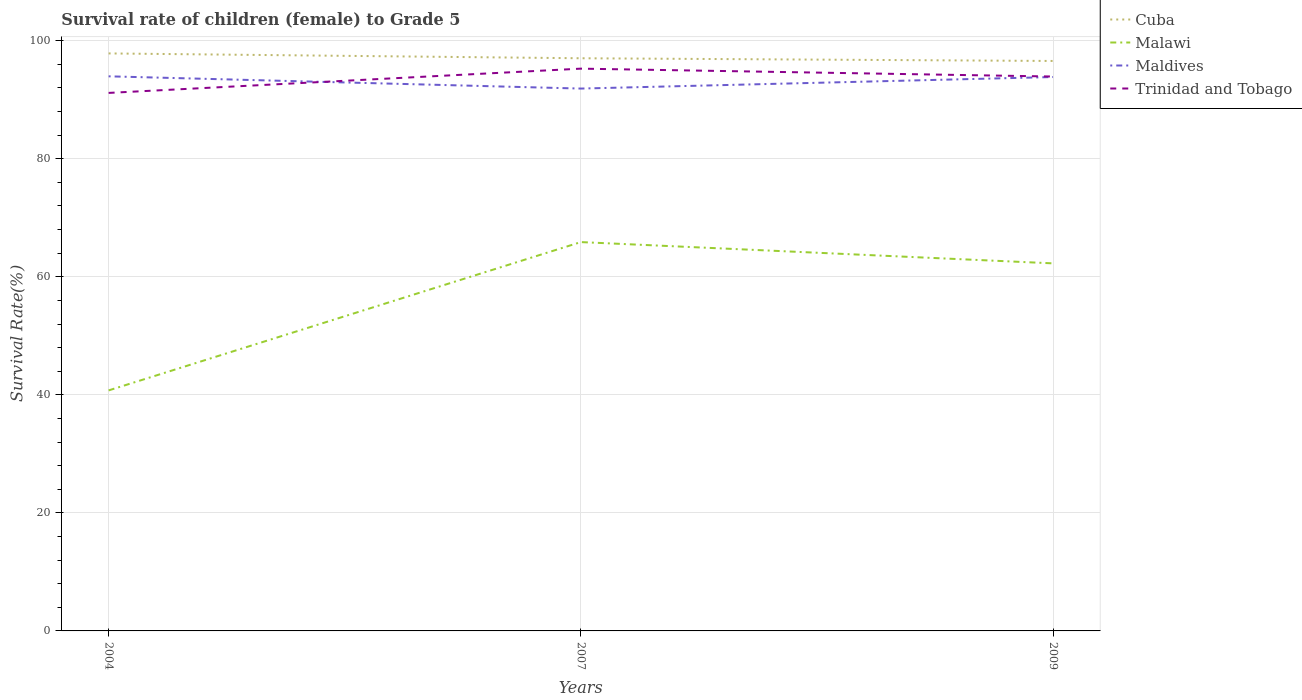How many different coloured lines are there?
Provide a short and direct response. 4. Does the line corresponding to Cuba intersect with the line corresponding to Malawi?
Keep it short and to the point. No. Across all years, what is the maximum survival rate of female children to grade 5 in Cuba?
Offer a very short reply. 96.57. What is the total survival rate of female children to grade 5 in Cuba in the graph?
Your response must be concise. 0.46. What is the difference between the highest and the second highest survival rate of female children to grade 5 in Maldives?
Make the answer very short. 2.07. What is the difference between the highest and the lowest survival rate of female children to grade 5 in Cuba?
Offer a very short reply. 1. Is the survival rate of female children to grade 5 in Cuba strictly greater than the survival rate of female children to grade 5 in Maldives over the years?
Your answer should be very brief. No. Does the graph contain grids?
Provide a short and direct response. Yes. How are the legend labels stacked?
Ensure brevity in your answer.  Vertical. What is the title of the graph?
Make the answer very short. Survival rate of children (female) to Grade 5. Does "Chad" appear as one of the legend labels in the graph?
Make the answer very short. No. What is the label or title of the Y-axis?
Make the answer very short. Survival Rate(%). What is the Survival Rate(%) of Cuba in 2004?
Give a very brief answer. 97.84. What is the Survival Rate(%) of Malawi in 2004?
Your response must be concise. 40.75. What is the Survival Rate(%) in Maldives in 2004?
Offer a terse response. 93.96. What is the Survival Rate(%) in Trinidad and Tobago in 2004?
Keep it short and to the point. 91.15. What is the Survival Rate(%) in Cuba in 2007?
Your answer should be very brief. 97.03. What is the Survival Rate(%) in Malawi in 2007?
Provide a succinct answer. 65.88. What is the Survival Rate(%) in Maldives in 2007?
Offer a very short reply. 91.89. What is the Survival Rate(%) in Trinidad and Tobago in 2007?
Provide a succinct answer. 95.27. What is the Survival Rate(%) of Cuba in 2009?
Give a very brief answer. 96.57. What is the Survival Rate(%) in Malawi in 2009?
Your answer should be very brief. 62.27. What is the Survival Rate(%) of Maldives in 2009?
Give a very brief answer. 93.84. What is the Survival Rate(%) in Trinidad and Tobago in 2009?
Offer a terse response. 93.93. Across all years, what is the maximum Survival Rate(%) of Cuba?
Make the answer very short. 97.84. Across all years, what is the maximum Survival Rate(%) in Malawi?
Give a very brief answer. 65.88. Across all years, what is the maximum Survival Rate(%) in Maldives?
Your answer should be very brief. 93.96. Across all years, what is the maximum Survival Rate(%) of Trinidad and Tobago?
Your answer should be very brief. 95.27. Across all years, what is the minimum Survival Rate(%) of Cuba?
Keep it short and to the point. 96.57. Across all years, what is the minimum Survival Rate(%) of Malawi?
Ensure brevity in your answer.  40.75. Across all years, what is the minimum Survival Rate(%) of Maldives?
Offer a very short reply. 91.89. Across all years, what is the minimum Survival Rate(%) of Trinidad and Tobago?
Keep it short and to the point. 91.15. What is the total Survival Rate(%) of Cuba in the graph?
Offer a very short reply. 291.44. What is the total Survival Rate(%) of Malawi in the graph?
Ensure brevity in your answer.  168.9. What is the total Survival Rate(%) of Maldives in the graph?
Keep it short and to the point. 279.7. What is the total Survival Rate(%) in Trinidad and Tobago in the graph?
Your response must be concise. 280.35. What is the difference between the Survival Rate(%) in Cuba in 2004 and that in 2007?
Your answer should be compact. 0.82. What is the difference between the Survival Rate(%) of Malawi in 2004 and that in 2007?
Make the answer very short. -25.13. What is the difference between the Survival Rate(%) of Maldives in 2004 and that in 2007?
Your answer should be very brief. 2.07. What is the difference between the Survival Rate(%) of Trinidad and Tobago in 2004 and that in 2007?
Ensure brevity in your answer.  -4.11. What is the difference between the Survival Rate(%) of Cuba in 2004 and that in 2009?
Give a very brief answer. 1.28. What is the difference between the Survival Rate(%) of Malawi in 2004 and that in 2009?
Provide a short and direct response. -21.53. What is the difference between the Survival Rate(%) in Maldives in 2004 and that in 2009?
Make the answer very short. 0.12. What is the difference between the Survival Rate(%) of Trinidad and Tobago in 2004 and that in 2009?
Your answer should be very brief. -2.78. What is the difference between the Survival Rate(%) in Cuba in 2007 and that in 2009?
Offer a very short reply. 0.46. What is the difference between the Survival Rate(%) in Malawi in 2007 and that in 2009?
Keep it short and to the point. 3.6. What is the difference between the Survival Rate(%) in Maldives in 2007 and that in 2009?
Keep it short and to the point. -1.95. What is the difference between the Survival Rate(%) in Trinidad and Tobago in 2007 and that in 2009?
Your answer should be very brief. 1.34. What is the difference between the Survival Rate(%) in Cuba in 2004 and the Survival Rate(%) in Malawi in 2007?
Your answer should be compact. 31.97. What is the difference between the Survival Rate(%) of Cuba in 2004 and the Survival Rate(%) of Maldives in 2007?
Your answer should be very brief. 5.95. What is the difference between the Survival Rate(%) in Cuba in 2004 and the Survival Rate(%) in Trinidad and Tobago in 2007?
Keep it short and to the point. 2.58. What is the difference between the Survival Rate(%) in Malawi in 2004 and the Survival Rate(%) in Maldives in 2007?
Provide a short and direct response. -51.14. What is the difference between the Survival Rate(%) of Malawi in 2004 and the Survival Rate(%) of Trinidad and Tobago in 2007?
Your response must be concise. -54.52. What is the difference between the Survival Rate(%) of Maldives in 2004 and the Survival Rate(%) of Trinidad and Tobago in 2007?
Provide a short and direct response. -1.3. What is the difference between the Survival Rate(%) in Cuba in 2004 and the Survival Rate(%) in Malawi in 2009?
Provide a short and direct response. 35.57. What is the difference between the Survival Rate(%) of Cuba in 2004 and the Survival Rate(%) of Maldives in 2009?
Offer a terse response. 4. What is the difference between the Survival Rate(%) in Cuba in 2004 and the Survival Rate(%) in Trinidad and Tobago in 2009?
Provide a short and direct response. 3.91. What is the difference between the Survival Rate(%) of Malawi in 2004 and the Survival Rate(%) of Maldives in 2009?
Your answer should be very brief. -53.1. What is the difference between the Survival Rate(%) in Malawi in 2004 and the Survival Rate(%) in Trinidad and Tobago in 2009?
Provide a short and direct response. -53.18. What is the difference between the Survival Rate(%) of Maldives in 2004 and the Survival Rate(%) of Trinidad and Tobago in 2009?
Provide a succinct answer. 0.04. What is the difference between the Survival Rate(%) of Cuba in 2007 and the Survival Rate(%) of Malawi in 2009?
Offer a very short reply. 34.75. What is the difference between the Survival Rate(%) in Cuba in 2007 and the Survival Rate(%) in Maldives in 2009?
Your response must be concise. 3.18. What is the difference between the Survival Rate(%) of Cuba in 2007 and the Survival Rate(%) of Trinidad and Tobago in 2009?
Make the answer very short. 3.1. What is the difference between the Survival Rate(%) of Malawi in 2007 and the Survival Rate(%) of Maldives in 2009?
Provide a succinct answer. -27.97. What is the difference between the Survival Rate(%) in Malawi in 2007 and the Survival Rate(%) in Trinidad and Tobago in 2009?
Provide a short and direct response. -28.05. What is the difference between the Survival Rate(%) of Maldives in 2007 and the Survival Rate(%) of Trinidad and Tobago in 2009?
Offer a terse response. -2.04. What is the average Survival Rate(%) in Cuba per year?
Provide a short and direct response. 97.15. What is the average Survival Rate(%) in Malawi per year?
Give a very brief answer. 56.3. What is the average Survival Rate(%) of Maldives per year?
Offer a very short reply. 93.23. What is the average Survival Rate(%) of Trinidad and Tobago per year?
Offer a terse response. 93.45. In the year 2004, what is the difference between the Survival Rate(%) of Cuba and Survival Rate(%) of Malawi?
Keep it short and to the point. 57.1. In the year 2004, what is the difference between the Survival Rate(%) of Cuba and Survival Rate(%) of Maldives?
Provide a short and direct response. 3.88. In the year 2004, what is the difference between the Survival Rate(%) of Cuba and Survival Rate(%) of Trinidad and Tobago?
Your answer should be compact. 6.69. In the year 2004, what is the difference between the Survival Rate(%) of Malawi and Survival Rate(%) of Maldives?
Offer a very short reply. -53.22. In the year 2004, what is the difference between the Survival Rate(%) of Malawi and Survival Rate(%) of Trinidad and Tobago?
Give a very brief answer. -50.4. In the year 2004, what is the difference between the Survival Rate(%) of Maldives and Survival Rate(%) of Trinidad and Tobago?
Make the answer very short. 2.81. In the year 2007, what is the difference between the Survival Rate(%) of Cuba and Survival Rate(%) of Malawi?
Keep it short and to the point. 31.15. In the year 2007, what is the difference between the Survival Rate(%) of Cuba and Survival Rate(%) of Maldives?
Your answer should be compact. 5.13. In the year 2007, what is the difference between the Survival Rate(%) of Cuba and Survival Rate(%) of Trinidad and Tobago?
Offer a very short reply. 1.76. In the year 2007, what is the difference between the Survival Rate(%) in Malawi and Survival Rate(%) in Maldives?
Ensure brevity in your answer.  -26.01. In the year 2007, what is the difference between the Survival Rate(%) of Malawi and Survival Rate(%) of Trinidad and Tobago?
Make the answer very short. -29.39. In the year 2007, what is the difference between the Survival Rate(%) in Maldives and Survival Rate(%) in Trinidad and Tobago?
Provide a short and direct response. -3.37. In the year 2009, what is the difference between the Survival Rate(%) in Cuba and Survival Rate(%) in Malawi?
Make the answer very short. 34.29. In the year 2009, what is the difference between the Survival Rate(%) of Cuba and Survival Rate(%) of Maldives?
Your answer should be very brief. 2.72. In the year 2009, what is the difference between the Survival Rate(%) in Cuba and Survival Rate(%) in Trinidad and Tobago?
Your response must be concise. 2.64. In the year 2009, what is the difference between the Survival Rate(%) in Malawi and Survival Rate(%) in Maldives?
Ensure brevity in your answer.  -31.57. In the year 2009, what is the difference between the Survival Rate(%) in Malawi and Survival Rate(%) in Trinidad and Tobago?
Your response must be concise. -31.66. In the year 2009, what is the difference between the Survival Rate(%) in Maldives and Survival Rate(%) in Trinidad and Tobago?
Your response must be concise. -0.09. What is the ratio of the Survival Rate(%) in Cuba in 2004 to that in 2007?
Ensure brevity in your answer.  1.01. What is the ratio of the Survival Rate(%) of Malawi in 2004 to that in 2007?
Provide a succinct answer. 0.62. What is the ratio of the Survival Rate(%) in Maldives in 2004 to that in 2007?
Provide a short and direct response. 1.02. What is the ratio of the Survival Rate(%) of Trinidad and Tobago in 2004 to that in 2007?
Provide a succinct answer. 0.96. What is the ratio of the Survival Rate(%) of Cuba in 2004 to that in 2009?
Give a very brief answer. 1.01. What is the ratio of the Survival Rate(%) in Malawi in 2004 to that in 2009?
Your answer should be very brief. 0.65. What is the ratio of the Survival Rate(%) of Trinidad and Tobago in 2004 to that in 2009?
Your answer should be very brief. 0.97. What is the ratio of the Survival Rate(%) in Cuba in 2007 to that in 2009?
Offer a very short reply. 1. What is the ratio of the Survival Rate(%) in Malawi in 2007 to that in 2009?
Your answer should be very brief. 1.06. What is the ratio of the Survival Rate(%) in Maldives in 2007 to that in 2009?
Provide a short and direct response. 0.98. What is the ratio of the Survival Rate(%) of Trinidad and Tobago in 2007 to that in 2009?
Offer a very short reply. 1.01. What is the difference between the highest and the second highest Survival Rate(%) of Cuba?
Your answer should be very brief. 0.82. What is the difference between the highest and the second highest Survival Rate(%) in Malawi?
Give a very brief answer. 3.6. What is the difference between the highest and the second highest Survival Rate(%) in Maldives?
Offer a terse response. 0.12. What is the difference between the highest and the second highest Survival Rate(%) of Trinidad and Tobago?
Provide a short and direct response. 1.34. What is the difference between the highest and the lowest Survival Rate(%) of Cuba?
Give a very brief answer. 1.28. What is the difference between the highest and the lowest Survival Rate(%) in Malawi?
Keep it short and to the point. 25.13. What is the difference between the highest and the lowest Survival Rate(%) of Maldives?
Provide a short and direct response. 2.07. What is the difference between the highest and the lowest Survival Rate(%) in Trinidad and Tobago?
Provide a short and direct response. 4.11. 